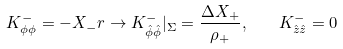<formula> <loc_0><loc_0><loc_500><loc_500>K _ { \phi \phi } ^ { - } = - X _ { - } r \rightarrow K _ { \hat { \phi } \hat { \phi } } ^ { - } | _ { \Sigma } = \frac { { \Delta } X _ { + } } { \rho _ { + } } , \quad K _ { \hat { z } \hat { z } } ^ { - } = 0</formula> 